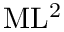Convert formula to latex. <formula><loc_0><loc_0><loc_500><loc_500>M L ^ { 2 }</formula> 